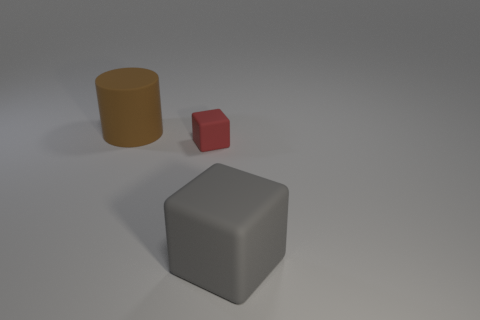Is there anything else that is the same shape as the brown rubber thing?
Make the answer very short. No. What is the size of the gray matte block?
Offer a very short reply. Large. How many cylinders have the same size as the red matte block?
Provide a short and direct response. 0. What number of other red objects are the same shape as the small rubber object?
Your answer should be compact. 0. Is the number of gray objects that are right of the gray object the same as the number of large green shiny spheres?
Make the answer very short. Yes. Is there anything else that is the same size as the red object?
Keep it short and to the point. No. There is another matte object that is the same size as the gray thing; what is its shape?
Give a very brief answer. Cylinder. Is there a green metal object of the same shape as the gray rubber object?
Provide a succinct answer. No. There is a large rubber thing that is behind the big thing on the right side of the brown rubber cylinder; is there a small red thing that is in front of it?
Offer a very short reply. Yes. Is the number of large gray matte blocks left of the gray thing greater than the number of big objects that are behind the big brown cylinder?
Ensure brevity in your answer.  No. 